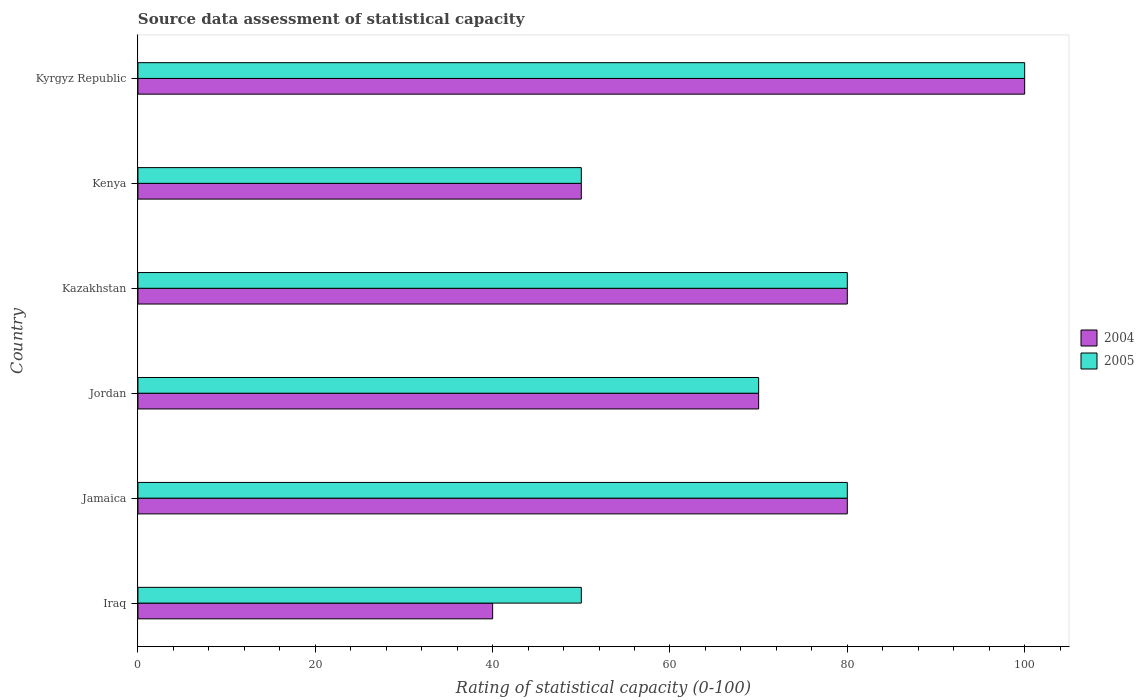How many different coloured bars are there?
Your answer should be compact. 2. How many groups of bars are there?
Your response must be concise. 6. Are the number of bars per tick equal to the number of legend labels?
Ensure brevity in your answer.  Yes. How many bars are there on the 4th tick from the top?
Offer a very short reply. 2. What is the label of the 1st group of bars from the top?
Offer a very short reply. Kyrgyz Republic. In how many cases, is the number of bars for a given country not equal to the number of legend labels?
Offer a very short reply. 0. What is the rating of statistical capacity in 2004 in Kyrgyz Republic?
Offer a terse response. 100. Across all countries, what is the maximum rating of statistical capacity in 2005?
Make the answer very short. 100. Across all countries, what is the minimum rating of statistical capacity in 2004?
Offer a terse response. 40. In which country was the rating of statistical capacity in 2004 maximum?
Your answer should be compact. Kyrgyz Republic. In which country was the rating of statistical capacity in 2005 minimum?
Your answer should be compact. Iraq. What is the total rating of statistical capacity in 2004 in the graph?
Make the answer very short. 420. What is the average rating of statistical capacity in 2004 per country?
Ensure brevity in your answer.  70. What is the difference between the rating of statistical capacity in 2005 and rating of statistical capacity in 2004 in Iraq?
Your response must be concise. 10. In how many countries, is the rating of statistical capacity in 2004 greater than the average rating of statistical capacity in 2004 taken over all countries?
Offer a very short reply. 3. How many bars are there?
Your answer should be compact. 12. Are all the bars in the graph horizontal?
Make the answer very short. Yes. Are the values on the major ticks of X-axis written in scientific E-notation?
Give a very brief answer. No. Does the graph contain any zero values?
Your response must be concise. No. Does the graph contain grids?
Your answer should be very brief. No. How many legend labels are there?
Make the answer very short. 2. What is the title of the graph?
Offer a terse response. Source data assessment of statistical capacity. What is the label or title of the X-axis?
Your answer should be compact. Rating of statistical capacity (0-100). What is the label or title of the Y-axis?
Give a very brief answer. Country. What is the Rating of statistical capacity (0-100) in 2004 in Jamaica?
Your response must be concise. 80. What is the Rating of statistical capacity (0-100) in 2005 in Jamaica?
Make the answer very short. 80. What is the Rating of statistical capacity (0-100) in 2005 in Jordan?
Ensure brevity in your answer.  70. What is the Rating of statistical capacity (0-100) of 2005 in Kazakhstan?
Keep it short and to the point. 80. What is the Rating of statistical capacity (0-100) in 2004 in Kenya?
Make the answer very short. 50. What is the Rating of statistical capacity (0-100) of 2005 in Kenya?
Offer a very short reply. 50. Across all countries, what is the maximum Rating of statistical capacity (0-100) in 2004?
Give a very brief answer. 100. Across all countries, what is the maximum Rating of statistical capacity (0-100) in 2005?
Ensure brevity in your answer.  100. What is the total Rating of statistical capacity (0-100) of 2004 in the graph?
Your answer should be very brief. 420. What is the total Rating of statistical capacity (0-100) of 2005 in the graph?
Your answer should be compact. 430. What is the difference between the Rating of statistical capacity (0-100) in 2005 in Iraq and that in Jamaica?
Provide a short and direct response. -30. What is the difference between the Rating of statistical capacity (0-100) in 2004 in Iraq and that in Kazakhstan?
Make the answer very short. -40. What is the difference between the Rating of statistical capacity (0-100) in 2005 in Iraq and that in Kazakhstan?
Offer a terse response. -30. What is the difference between the Rating of statistical capacity (0-100) in 2005 in Iraq and that in Kenya?
Give a very brief answer. 0. What is the difference between the Rating of statistical capacity (0-100) in 2004 in Iraq and that in Kyrgyz Republic?
Your answer should be compact. -60. What is the difference between the Rating of statistical capacity (0-100) of 2005 in Iraq and that in Kyrgyz Republic?
Offer a very short reply. -50. What is the difference between the Rating of statistical capacity (0-100) in 2005 in Jamaica and that in Jordan?
Provide a short and direct response. 10. What is the difference between the Rating of statistical capacity (0-100) of 2004 in Jamaica and that in Kenya?
Keep it short and to the point. 30. What is the difference between the Rating of statistical capacity (0-100) in 2004 in Jordan and that in Kazakhstan?
Give a very brief answer. -10. What is the difference between the Rating of statistical capacity (0-100) in 2005 in Jordan and that in Kazakhstan?
Give a very brief answer. -10. What is the difference between the Rating of statistical capacity (0-100) in 2004 in Jordan and that in Kenya?
Provide a short and direct response. 20. What is the difference between the Rating of statistical capacity (0-100) of 2005 in Jordan and that in Kenya?
Offer a terse response. 20. What is the difference between the Rating of statistical capacity (0-100) in 2004 in Jordan and that in Kyrgyz Republic?
Offer a terse response. -30. What is the difference between the Rating of statistical capacity (0-100) in 2004 in Kazakhstan and that in Kyrgyz Republic?
Ensure brevity in your answer.  -20. What is the difference between the Rating of statistical capacity (0-100) of 2005 in Kenya and that in Kyrgyz Republic?
Offer a terse response. -50. What is the difference between the Rating of statistical capacity (0-100) of 2004 in Iraq and the Rating of statistical capacity (0-100) of 2005 in Kazakhstan?
Ensure brevity in your answer.  -40. What is the difference between the Rating of statistical capacity (0-100) of 2004 in Iraq and the Rating of statistical capacity (0-100) of 2005 in Kenya?
Your response must be concise. -10. What is the difference between the Rating of statistical capacity (0-100) of 2004 in Iraq and the Rating of statistical capacity (0-100) of 2005 in Kyrgyz Republic?
Provide a short and direct response. -60. What is the difference between the Rating of statistical capacity (0-100) of 2004 in Jamaica and the Rating of statistical capacity (0-100) of 2005 in Jordan?
Your response must be concise. 10. What is the difference between the Rating of statistical capacity (0-100) in 2004 in Jamaica and the Rating of statistical capacity (0-100) in 2005 in Kazakhstan?
Your response must be concise. 0. What is the difference between the Rating of statistical capacity (0-100) of 2004 in Jamaica and the Rating of statistical capacity (0-100) of 2005 in Kyrgyz Republic?
Make the answer very short. -20. What is the difference between the Rating of statistical capacity (0-100) of 2004 in Jordan and the Rating of statistical capacity (0-100) of 2005 in Kazakhstan?
Offer a terse response. -10. What is the difference between the Rating of statistical capacity (0-100) of 2004 in Jordan and the Rating of statistical capacity (0-100) of 2005 in Kenya?
Ensure brevity in your answer.  20. What is the difference between the Rating of statistical capacity (0-100) of 2004 in Jordan and the Rating of statistical capacity (0-100) of 2005 in Kyrgyz Republic?
Your answer should be very brief. -30. What is the difference between the Rating of statistical capacity (0-100) of 2004 in Kazakhstan and the Rating of statistical capacity (0-100) of 2005 in Kenya?
Keep it short and to the point. 30. What is the average Rating of statistical capacity (0-100) in 2005 per country?
Make the answer very short. 71.67. What is the difference between the Rating of statistical capacity (0-100) in 2004 and Rating of statistical capacity (0-100) in 2005 in Jamaica?
Keep it short and to the point. 0. What is the difference between the Rating of statistical capacity (0-100) in 2004 and Rating of statistical capacity (0-100) in 2005 in Jordan?
Provide a succinct answer. 0. What is the difference between the Rating of statistical capacity (0-100) of 2004 and Rating of statistical capacity (0-100) of 2005 in Kenya?
Keep it short and to the point. 0. What is the ratio of the Rating of statistical capacity (0-100) of 2005 in Iraq to that in Jamaica?
Ensure brevity in your answer.  0.62. What is the ratio of the Rating of statistical capacity (0-100) of 2004 in Iraq to that in Jordan?
Ensure brevity in your answer.  0.57. What is the ratio of the Rating of statistical capacity (0-100) in 2005 in Iraq to that in Jordan?
Your response must be concise. 0.71. What is the ratio of the Rating of statistical capacity (0-100) in 2004 in Iraq to that in Kazakhstan?
Offer a terse response. 0.5. What is the ratio of the Rating of statistical capacity (0-100) of 2004 in Iraq to that in Kenya?
Provide a succinct answer. 0.8. What is the ratio of the Rating of statistical capacity (0-100) in 2004 in Iraq to that in Kyrgyz Republic?
Provide a short and direct response. 0.4. What is the ratio of the Rating of statistical capacity (0-100) in 2005 in Iraq to that in Kyrgyz Republic?
Offer a very short reply. 0.5. What is the ratio of the Rating of statistical capacity (0-100) in 2004 in Jamaica to that in Jordan?
Provide a succinct answer. 1.14. What is the ratio of the Rating of statistical capacity (0-100) of 2005 in Jamaica to that in Jordan?
Your answer should be very brief. 1.14. What is the ratio of the Rating of statistical capacity (0-100) in 2004 in Jamaica to that in Kenya?
Your answer should be very brief. 1.6. What is the ratio of the Rating of statistical capacity (0-100) in 2005 in Jamaica to that in Kenya?
Provide a short and direct response. 1.6. What is the ratio of the Rating of statistical capacity (0-100) of 2005 in Jamaica to that in Kyrgyz Republic?
Keep it short and to the point. 0.8. What is the ratio of the Rating of statistical capacity (0-100) in 2005 in Jordan to that in Kazakhstan?
Offer a very short reply. 0.88. What is the ratio of the Rating of statistical capacity (0-100) of 2005 in Jordan to that in Kenya?
Provide a short and direct response. 1.4. What is the ratio of the Rating of statistical capacity (0-100) of 2004 in Jordan to that in Kyrgyz Republic?
Your answer should be very brief. 0.7. What is the ratio of the Rating of statistical capacity (0-100) in 2005 in Jordan to that in Kyrgyz Republic?
Make the answer very short. 0.7. What is the ratio of the Rating of statistical capacity (0-100) in 2004 in Kazakhstan to that in Kenya?
Your answer should be compact. 1.6. What is the ratio of the Rating of statistical capacity (0-100) in 2005 in Kazakhstan to that in Kenya?
Provide a short and direct response. 1.6. What is the ratio of the Rating of statistical capacity (0-100) of 2004 in Kenya to that in Kyrgyz Republic?
Provide a short and direct response. 0.5. 